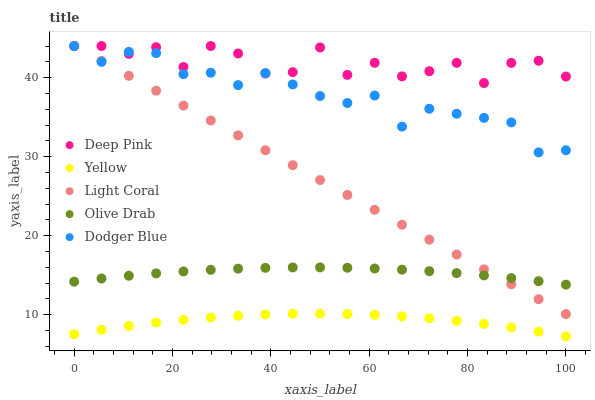Does Yellow have the minimum area under the curve?
Answer yes or no. Yes. Does Deep Pink have the maximum area under the curve?
Answer yes or no. Yes. Does Dodger Blue have the minimum area under the curve?
Answer yes or no. No. Does Dodger Blue have the maximum area under the curve?
Answer yes or no. No. Is Light Coral the smoothest?
Answer yes or no. Yes. Is Deep Pink the roughest?
Answer yes or no. Yes. Is Dodger Blue the smoothest?
Answer yes or no. No. Is Dodger Blue the roughest?
Answer yes or no. No. Does Yellow have the lowest value?
Answer yes or no. Yes. Does Dodger Blue have the lowest value?
Answer yes or no. No. Does Dodger Blue have the highest value?
Answer yes or no. Yes. Does Olive Drab have the highest value?
Answer yes or no. No. Is Olive Drab less than Dodger Blue?
Answer yes or no. Yes. Is Light Coral greater than Yellow?
Answer yes or no. Yes. Does Light Coral intersect Olive Drab?
Answer yes or no. Yes. Is Light Coral less than Olive Drab?
Answer yes or no. No. Is Light Coral greater than Olive Drab?
Answer yes or no. No. Does Olive Drab intersect Dodger Blue?
Answer yes or no. No. 